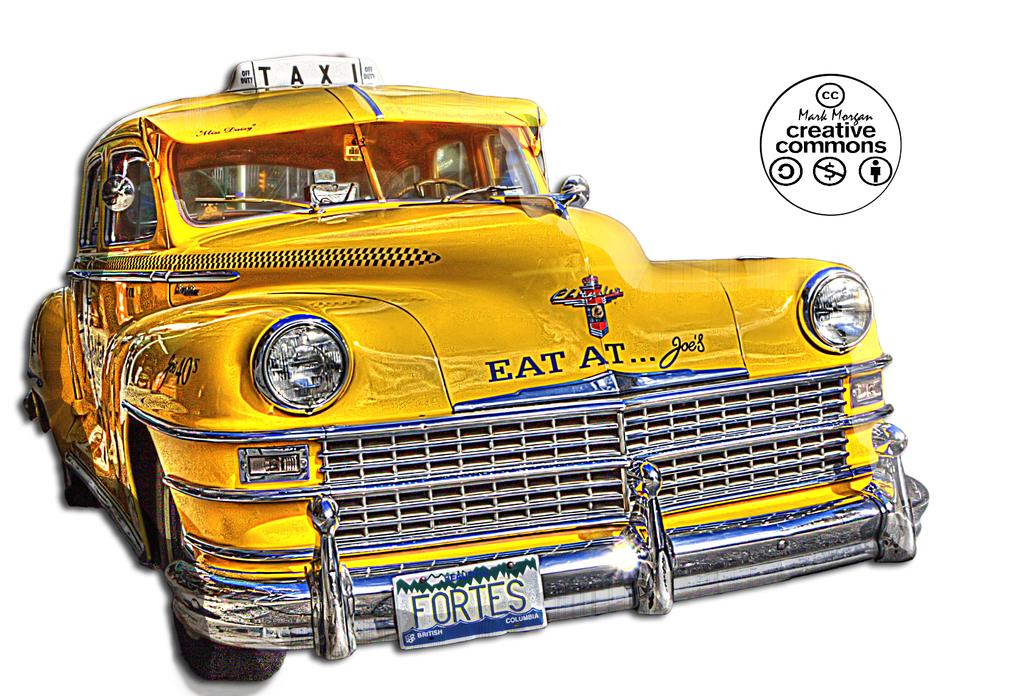<image>
Create a compact narrative representing the image presented. The license plate of a yellow taxi reads "FORTES." 